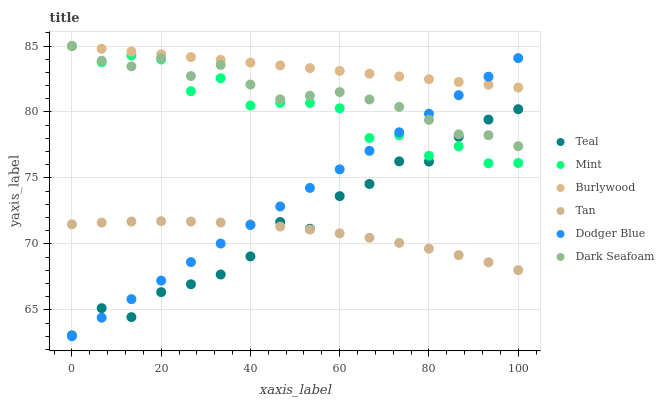Does Tan have the minimum area under the curve?
Answer yes or no. Yes. Does Burlywood have the maximum area under the curve?
Answer yes or no. Yes. Does Dark Seafoam have the minimum area under the curve?
Answer yes or no. No. Does Dark Seafoam have the maximum area under the curve?
Answer yes or no. No. Is Dodger Blue the smoothest?
Answer yes or no. Yes. Is Mint the roughest?
Answer yes or no. Yes. Is Dark Seafoam the smoothest?
Answer yes or no. No. Is Dark Seafoam the roughest?
Answer yes or no. No. Does Dodger Blue have the lowest value?
Answer yes or no. Yes. Does Dark Seafoam have the lowest value?
Answer yes or no. No. Does Mint have the highest value?
Answer yes or no. Yes. Does Dodger Blue have the highest value?
Answer yes or no. No. Is Teal less than Burlywood?
Answer yes or no. Yes. Is Mint greater than Tan?
Answer yes or no. Yes. Does Dark Seafoam intersect Dodger Blue?
Answer yes or no. Yes. Is Dark Seafoam less than Dodger Blue?
Answer yes or no. No. Is Dark Seafoam greater than Dodger Blue?
Answer yes or no. No. Does Teal intersect Burlywood?
Answer yes or no. No. 